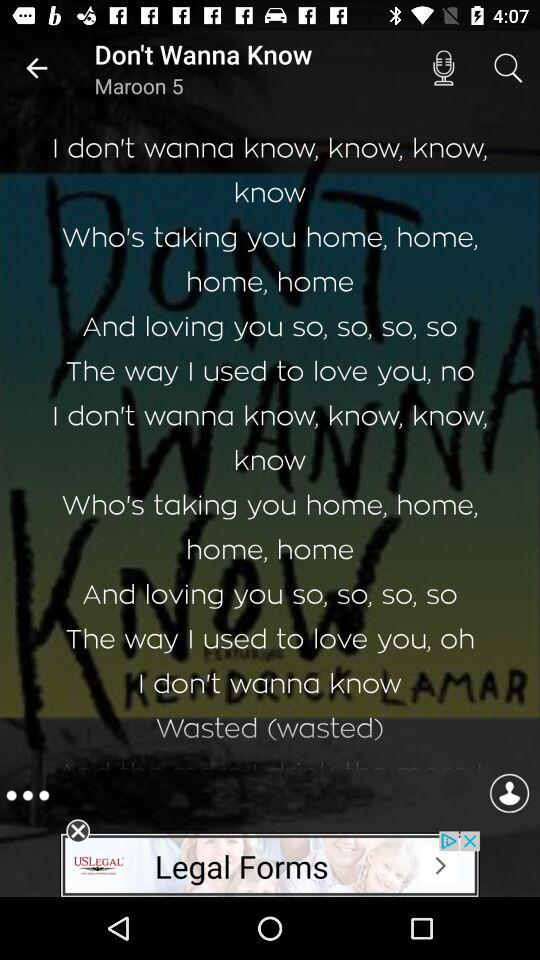Who's the artist of the song? The artist of the song is "Maroon 5". 